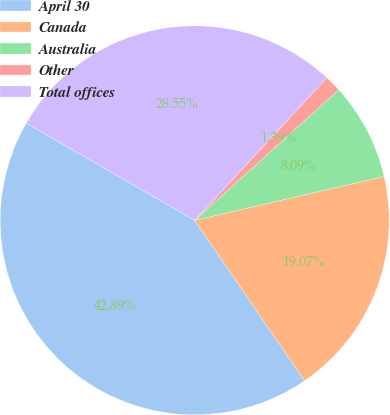<chart> <loc_0><loc_0><loc_500><loc_500><pie_chart><fcel>April 30<fcel>Canada<fcel>Australia<fcel>Other<fcel>Total offices<nl><fcel>42.89%<fcel>19.07%<fcel>8.09%<fcel>1.39%<fcel>28.55%<nl></chart> 